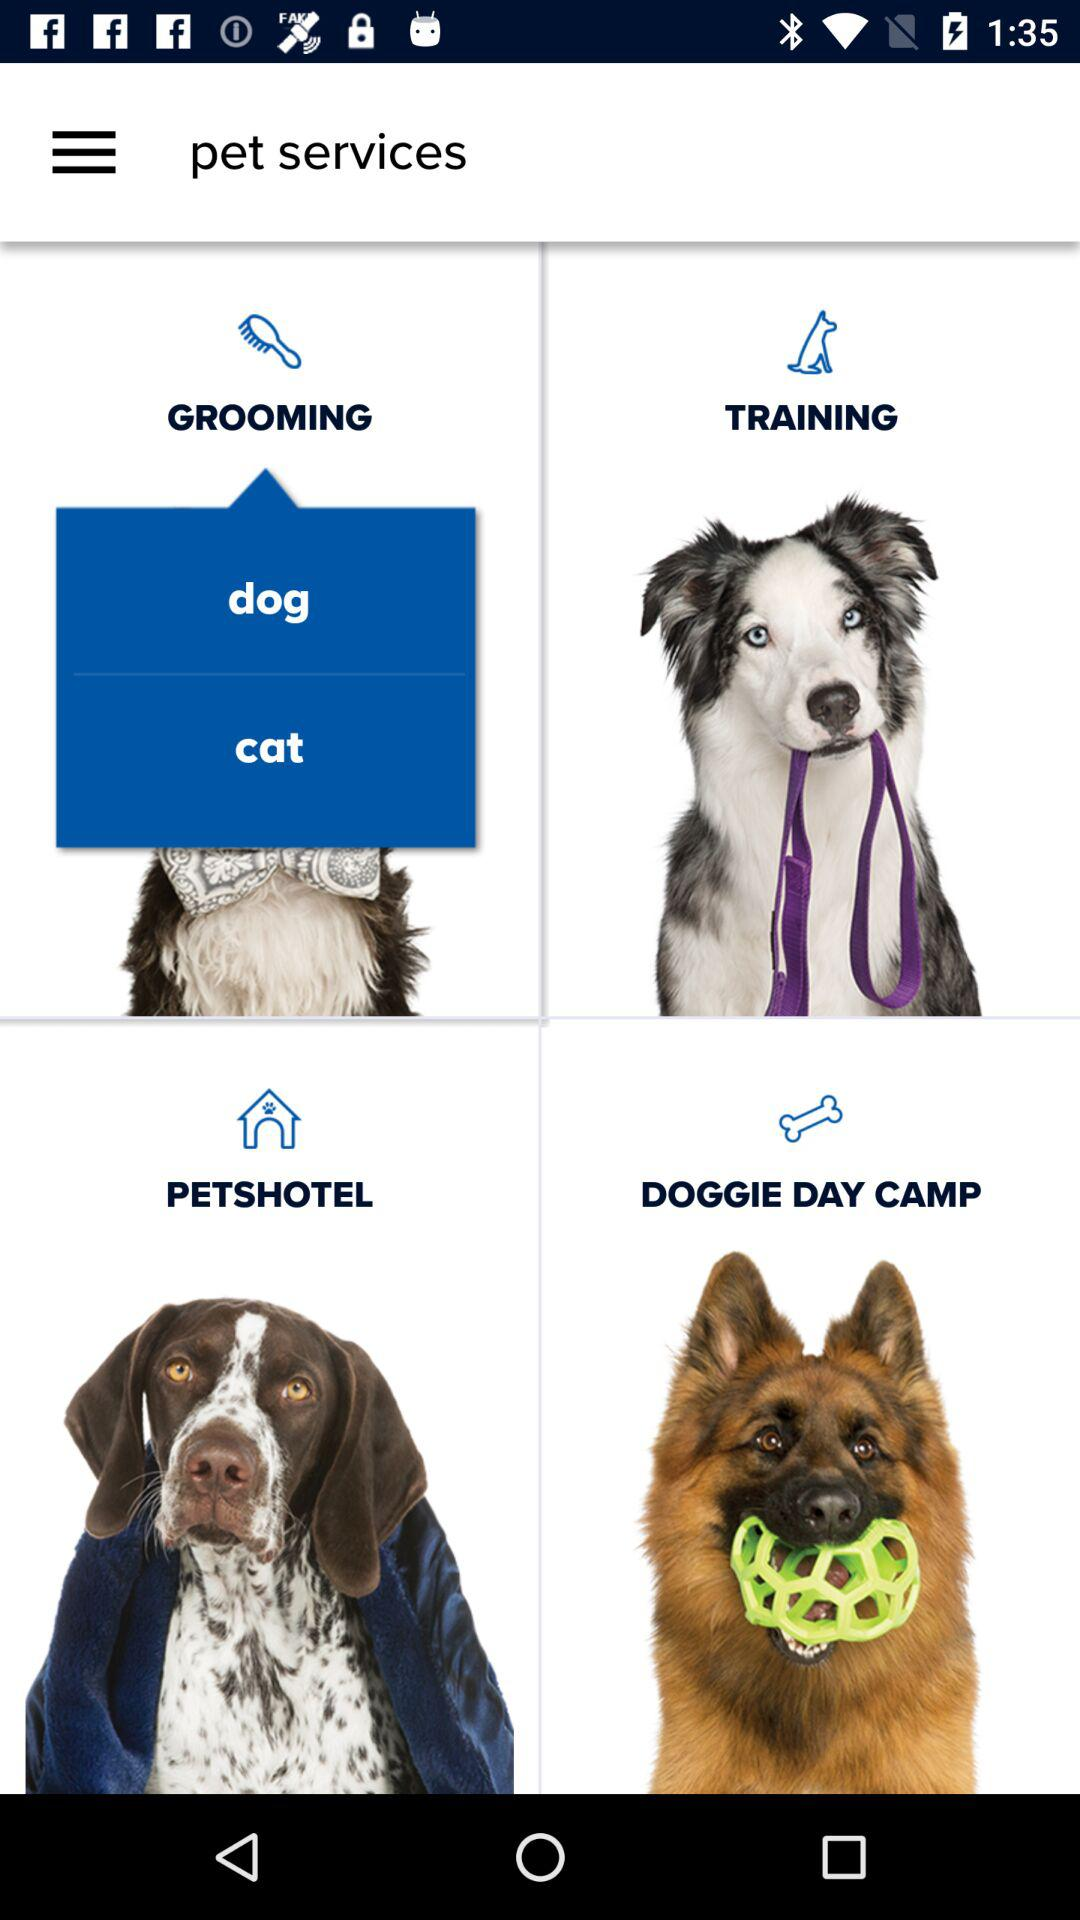Which pet options are available for grooming? The available pet options for grooming are "dog" and "cat". 